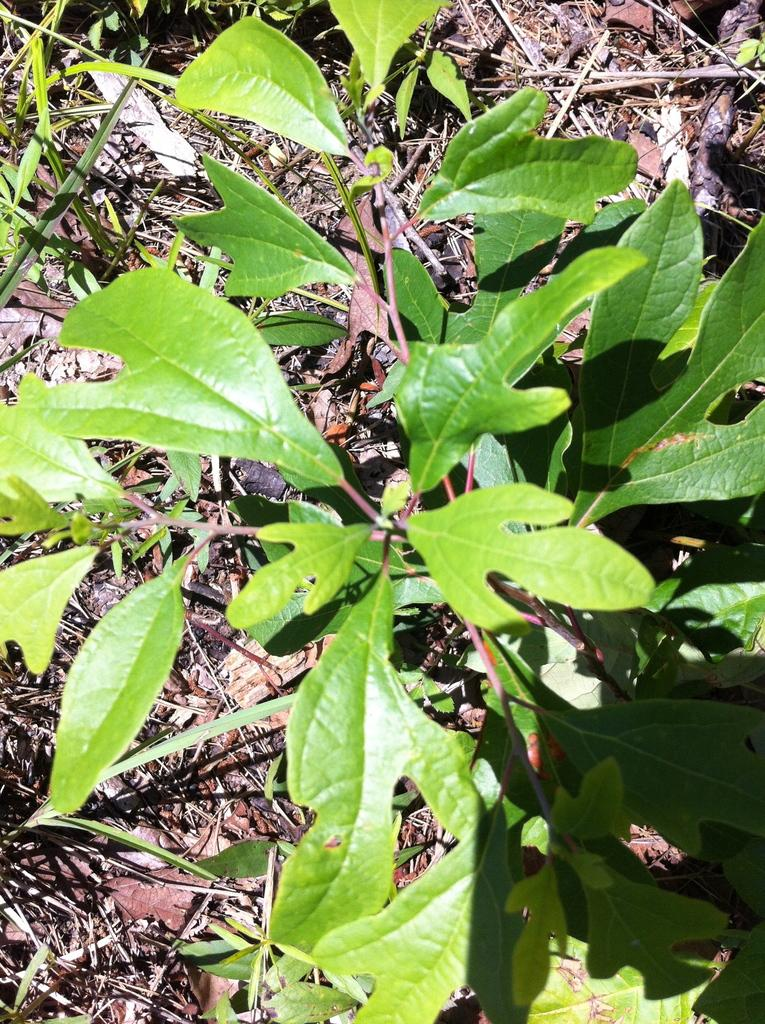What is the main subject of the image? The main subject of the image is plants. Where are the plants located in the image? The plants are in the center of the image. What degree does the cactus have in the image? There is no cactus present in the image, and therefore no degree can be attributed to it. 